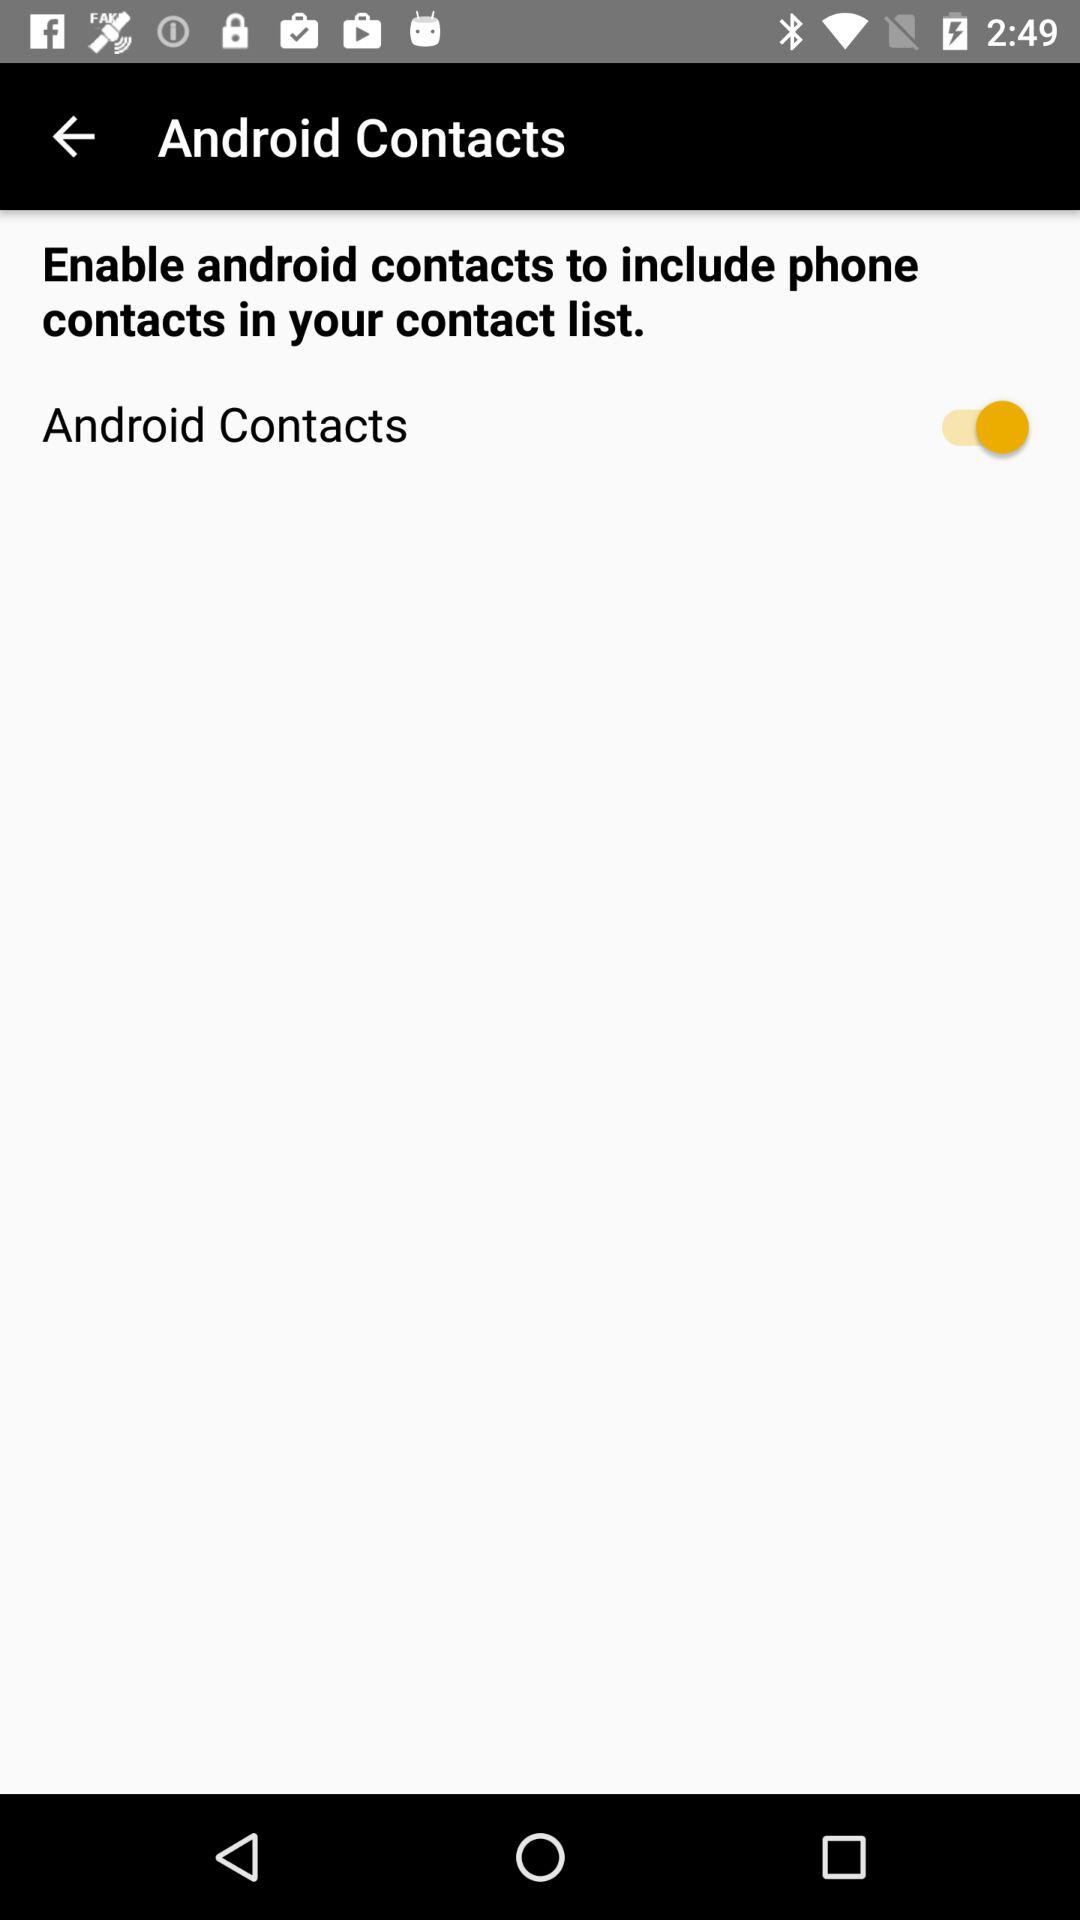What is the current status of "Android Contacts"? The status is "on". 